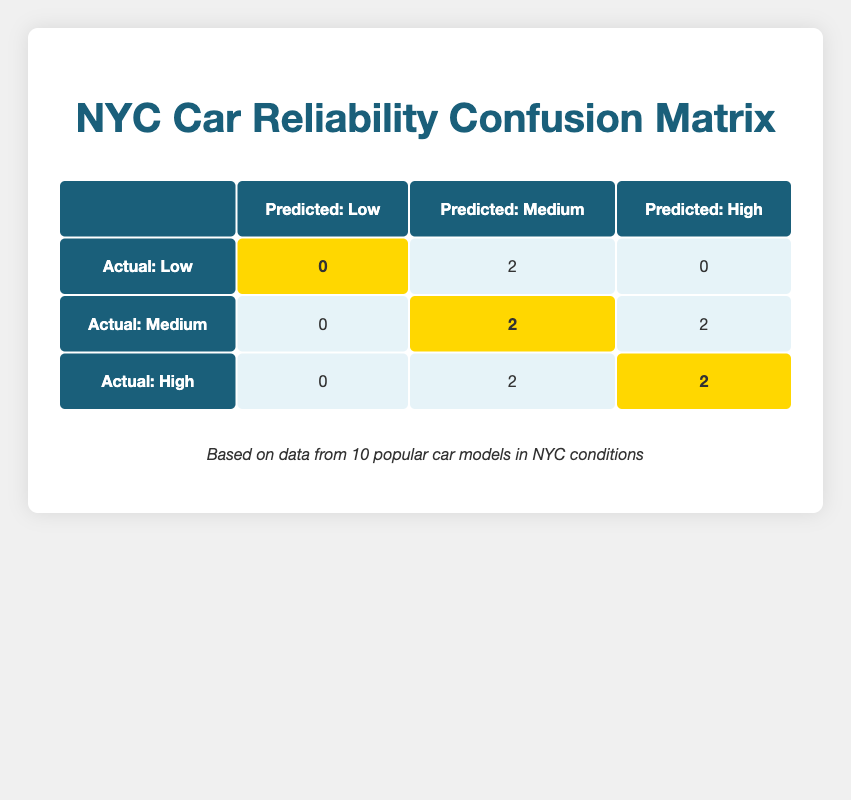What is the total number of cars that had a predicted reliability of 'High' and an actual performance of 'High'? From the table, we see two cars: Toyota Camry and Subaru Outback, both classified with 'High' predicted reliability and 'High' actual performance. Therefore, the total count is 2.
Answer: 2 How many cars were predicted to have 'Medium' reliability? The table shows four cars with 'Medium' predicted reliability: Ford Fusion, Chevrolet Malibu, Kia Forte, and Volkswagen Jetta, which gives us a total of 4 cars.
Answer: 4 Is there any car that had 'Low' actual performance and was predicted to have 'High' reliability? Examining the table indicates there are no cars that are marked as 'High' in predicted reliability and 'Low' in actual performance, therefore the answer is no.
Answer: No What percentage of cars with 'Medium' actual performance had a predicted reliability of 'Medium'? There are 2 cars with 'Medium' performance that are predicted to have 'Medium' reliability. The total number of cars with 'Medium' actual performance is 4 (2 Medium/Medium + 2 High/Medium). Thus, the percentage is (2/4) * 100 = 50%.
Answer: 50% If we consider only the cars with 'High' actual performance, how many had a predicted reliability of 'Medium'? The table shows that only Hyundai Elantra performed 'High' while being predicted as 'Medium'. Thus, there is 1 car meeting these criteria.
Answer: 1 How many cars had both predicted reliability and actual performance classified as 'Medium'? The table identifies 2 cars that fall into this category: Chevrolet Malibu and Kia Forte. Therefore, the total is 2 cars.
Answer: 2 What is the ratio of cars predicted to be 'Medium' against those predicted to be 'High'? From the table, there are 4 cars with 'Medium' predicted reliability (Ford Fusion, Chevrolet Malibu, Kia Forte, and Volkswagen Jetta) and 4 cars with 'High' predicted reliability (Toyota Camry, Subaru Outback, Mazda3, and Hyundai Elantra). Hence, the ratio is 4 to 4, or simplified to 1 to 1.
Answer: 1 to 1 How many cars actually performed 'Low'? Based on the table, there are 3 cars with 'Low' actual performance: Ford Fusion and Nissan Altima (both predicted Medium), leaving the total number of cars at 3.
Answer: 3 